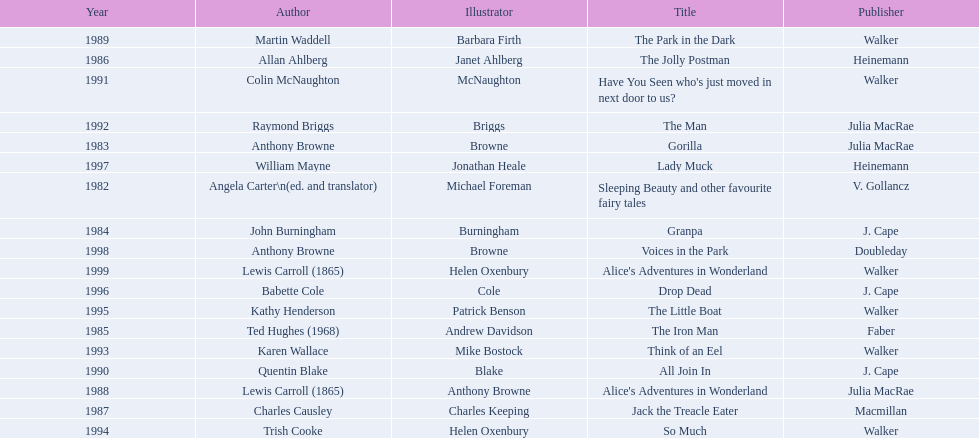How many occasions has anthony browne earned a kurt maschler award for illustration? 3. 